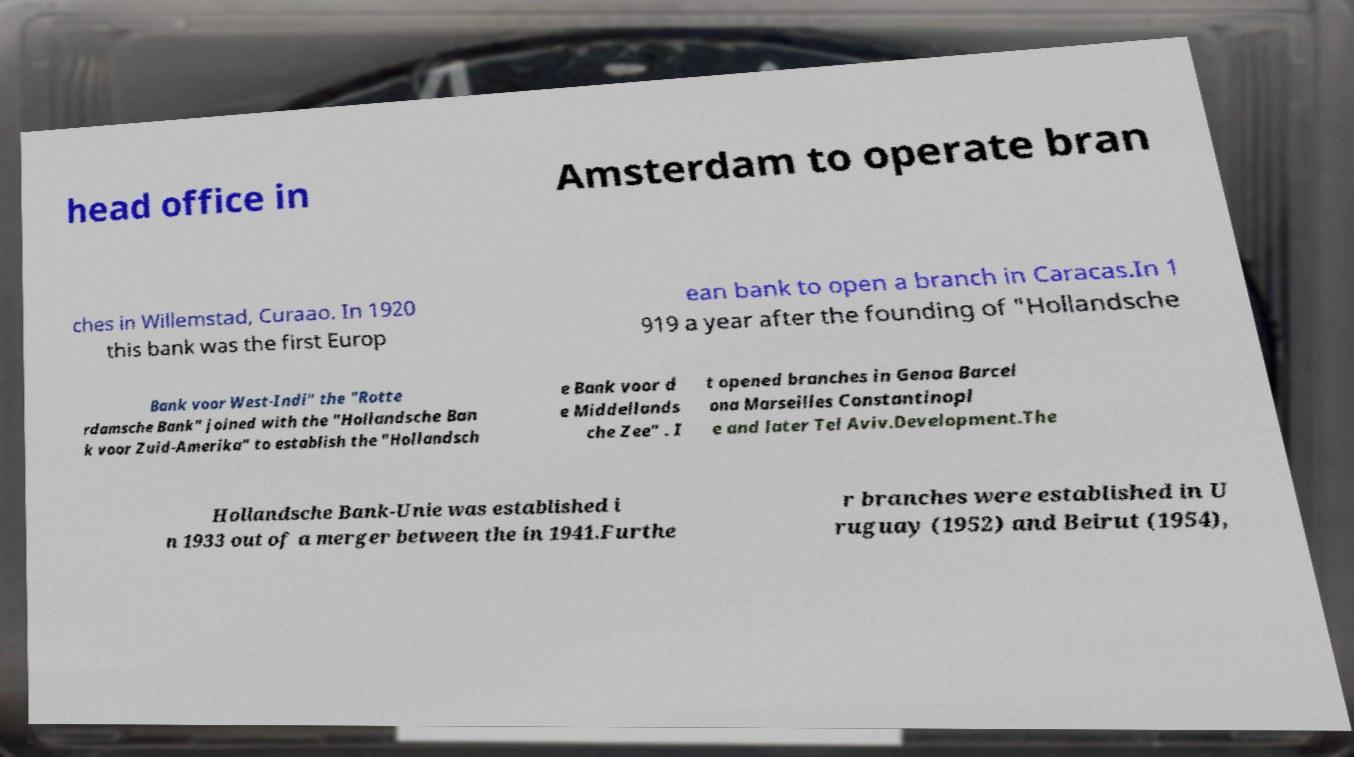For documentation purposes, I need the text within this image transcribed. Could you provide that? head office in Amsterdam to operate bran ches in Willemstad, Curaao. In 1920 this bank was the first Europ ean bank to open a branch in Caracas.In 1 919 a year after the founding of "Hollandsche Bank voor West-Indi" the "Rotte rdamsche Bank" joined with the "Hollandsche Ban k voor Zuid-Amerika" to establish the "Hollandsch e Bank voor d e Middellands che Zee" . I t opened branches in Genoa Barcel ona Marseilles Constantinopl e and later Tel Aviv.Development.The Hollandsche Bank-Unie was established i n 1933 out of a merger between the in 1941.Furthe r branches were established in U ruguay (1952) and Beirut (1954), 